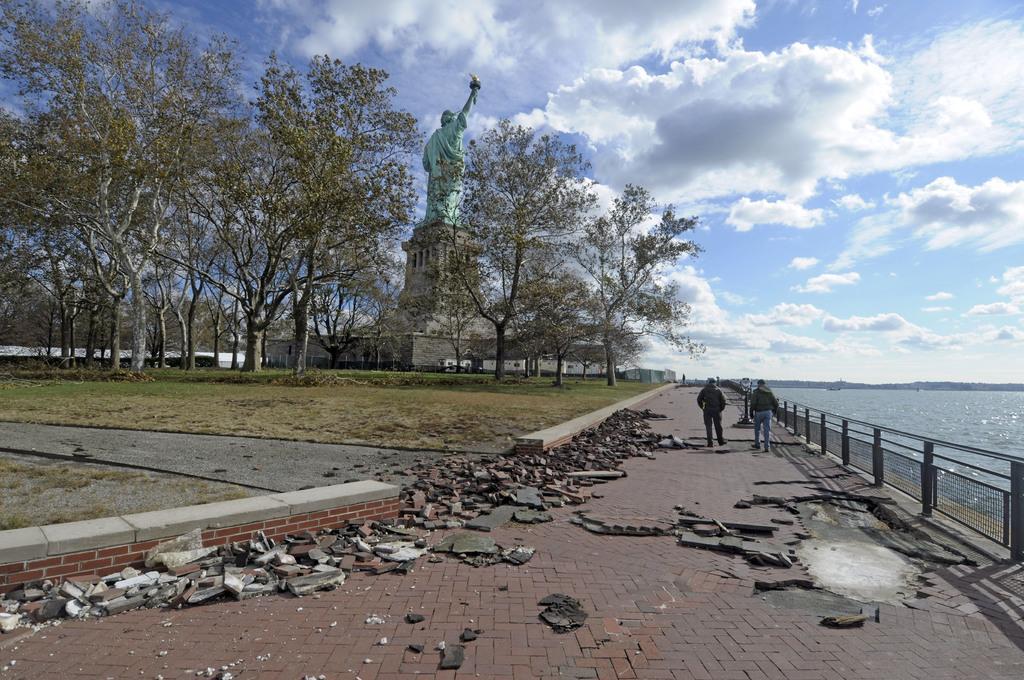Please provide a concise description of this image. In this image we can see two persons, ground, grass, plants, trees, statue, road, tiles, fence, water, and buildings. In the background there is sky with clouds. 